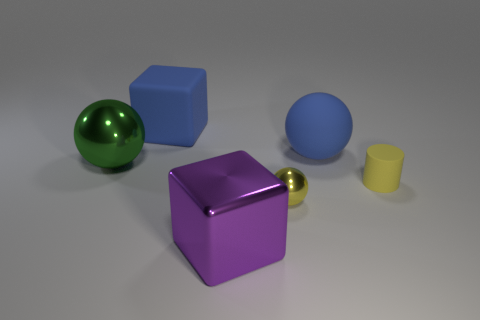Add 3 red cylinders. How many objects exist? 9 Subtract all green balls. How many balls are left? 2 Subtract 1 spheres. How many spheres are left? 2 Subtract all gray spheres. Subtract all red cylinders. How many spheres are left? 3 Subtract 1 purple blocks. How many objects are left? 5 Subtract all blocks. How many objects are left? 4 Subtract all metallic balls. Subtract all purple metallic blocks. How many objects are left? 3 Add 4 rubber balls. How many rubber balls are left? 5 Add 1 large metal objects. How many large metal objects exist? 3 